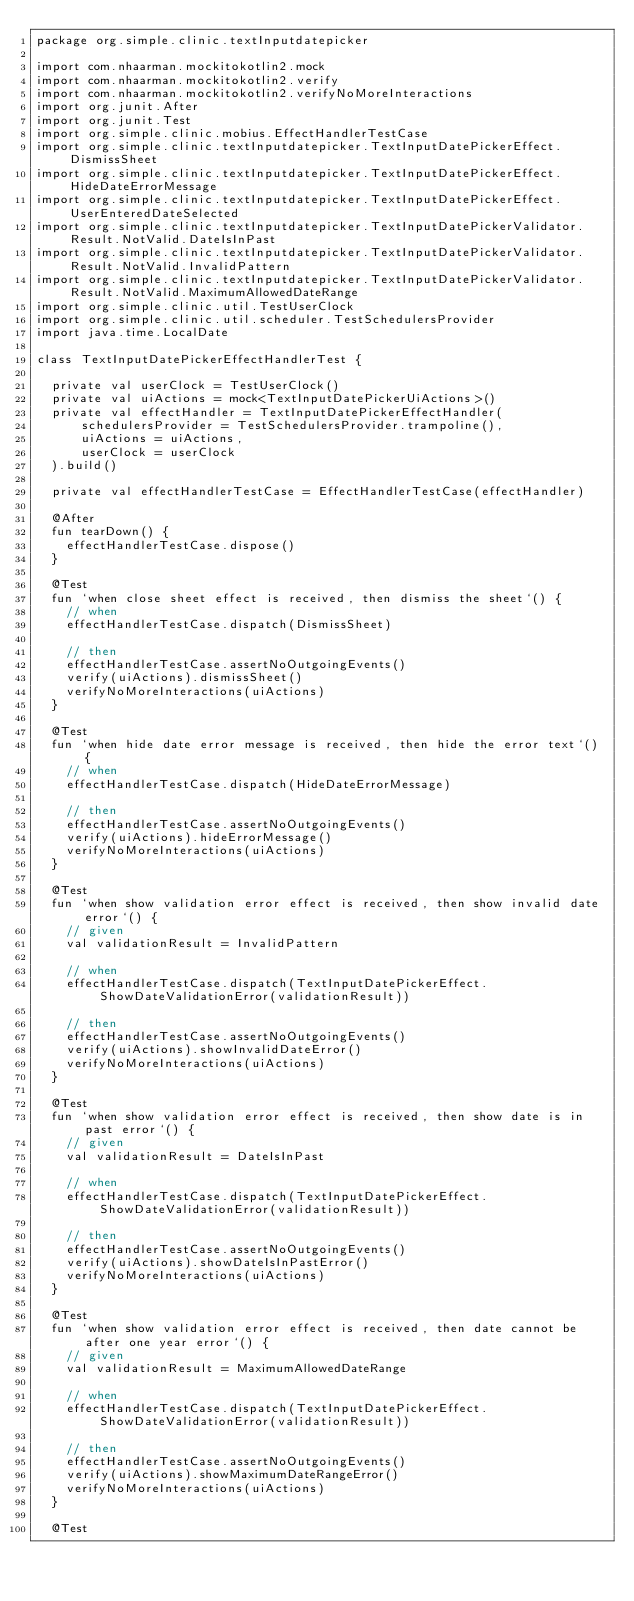Convert code to text. <code><loc_0><loc_0><loc_500><loc_500><_Kotlin_>package org.simple.clinic.textInputdatepicker

import com.nhaarman.mockitokotlin2.mock
import com.nhaarman.mockitokotlin2.verify
import com.nhaarman.mockitokotlin2.verifyNoMoreInteractions
import org.junit.After
import org.junit.Test
import org.simple.clinic.mobius.EffectHandlerTestCase
import org.simple.clinic.textInputdatepicker.TextInputDatePickerEffect.DismissSheet
import org.simple.clinic.textInputdatepicker.TextInputDatePickerEffect.HideDateErrorMessage
import org.simple.clinic.textInputdatepicker.TextInputDatePickerEffect.UserEnteredDateSelected
import org.simple.clinic.textInputdatepicker.TextInputDatePickerValidator.Result.NotValid.DateIsInPast
import org.simple.clinic.textInputdatepicker.TextInputDatePickerValidator.Result.NotValid.InvalidPattern
import org.simple.clinic.textInputdatepicker.TextInputDatePickerValidator.Result.NotValid.MaximumAllowedDateRange
import org.simple.clinic.util.TestUserClock
import org.simple.clinic.util.scheduler.TestSchedulersProvider
import java.time.LocalDate

class TextInputDatePickerEffectHandlerTest {

  private val userClock = TestUserClock()
  private val uiActions = mock<TextInputDatePickerUiActions>()
  private val effectHandler = TextInputDatePickerEffectHandler(
      schedulersProvider = TestSchedulersProvider.trampoline(),
      uiActions = uiActions,
      userClock = userClock
  ).build()

  private val effectHandlerTestCase = EffectHandlerTestCase(effectHandler)

  @After
  fun tearDown() {
    effectHandlerTestCase.dispose()
  }

  @Test
  fun `when close sheet effect is received, then dismiss the sheet`() {
    // when
    effectHandlerTestCase.dispatch(DismissSheet)

    // then
    effectHandlerTestCase.assertNoOutgoingEvents()
    verify(uiActions).dismissSheet()
    verifyNoMoreInteractions(uiActions)
  }

  @Test
  fun `when hide date error message is received, then hide the error text`() {
    // when
    effectHandlerTestCase.dispatch(HideDateErrorMessage)

    // then
    effectHandlerTestCase.assertNoOutgoingEvents()
    verify(uiActions).hideErrorMessage()
    verifyNoMoreInteractions(uiActions)
  }

  @Test
  fun `when show validation error effect is received, then show invalid date error`() {
    // given
    val validationResult = InvalidPattern

    // when
    effectHandlerTestCase.dispatch(TextInputDatePickerEffect.ShowDateValidationError(validationResult))

    // then
    effectHandlerTestCase.assertNoOutgoingEvents()
    verify(uiActions).showInvalidDateError()
    verifyNoMoreInteractions(uiActions)
  }

  @Test
  fun `when show validation error effect is received, then show date is in past error`() {
    // given
    val validationResult = DateIsInPast

    // when
    effectHandlerTestCase.dispatch(TextInputDatePickerEffect.ShowDateValidationError(validationResult))

    // then
    effectHandlerTestCase.assertNoOutgoingEvents()
    verify(uiActions).showDateIsInPastError()
    verifyNoMoreInteractions(uiActions)
  }

  @Test
  fun `when show validation error effect is received, then date cannot be after one year error`() {
    // given
    val validationResult = MaximumAllowedDateRange

    // when
    effectHandlerTestCase.dispatch(TextInputDatePickerEffect.ShowDateValidationError(validationResult))

    // then
    effectHandlerTestCase.assertNoOutgoingEvents()
    verify(uiActions).showMaximumDateRangeError()
    verifyNoMoreInteractions(uiActions)
  }

  @Test</code> 